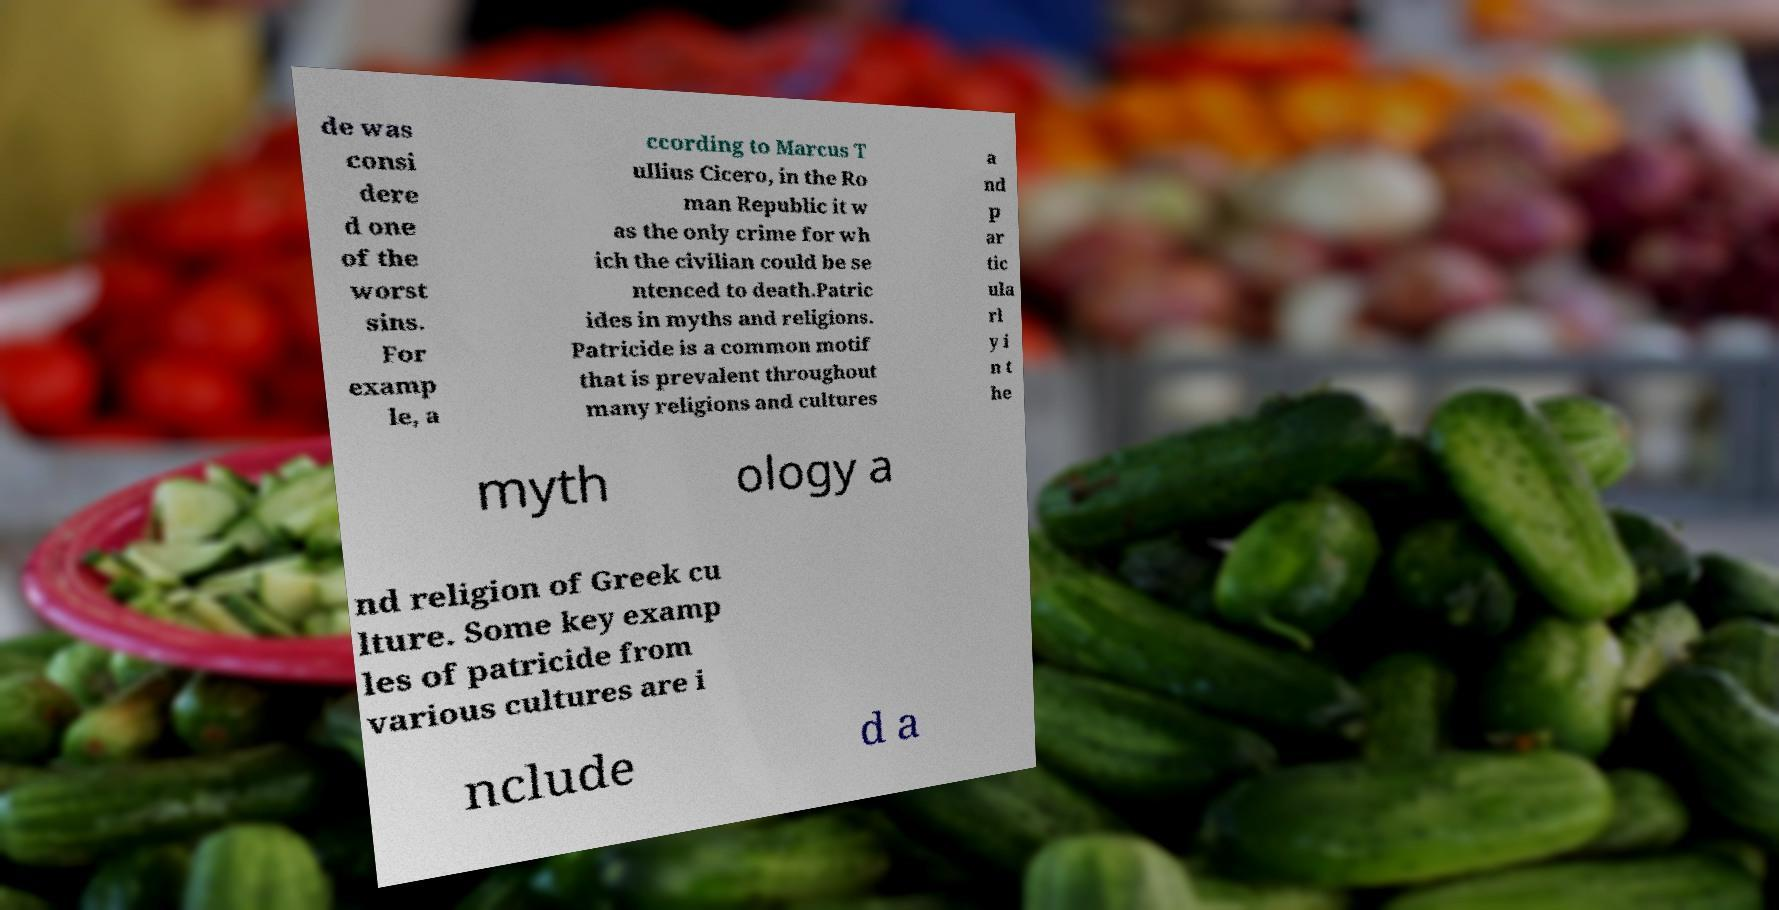Please read and relay the text visible in this image. What does it say? de was consi dere d one of the worst sins. For examp le, a ccording to Marcus T ullius Cicero, in the Ro man Republic it w as the only crime for wh ich the civilian could be se ntenced to death.Patric ides in myths and religions. Patricide is a common motif that is prevalent throughout many religions and cultures a nd p ar tic ula rl y i n t he myth ology a nd religion of Greek cu lture. Some key examp les of patricide from various cultures are i nclude d a 